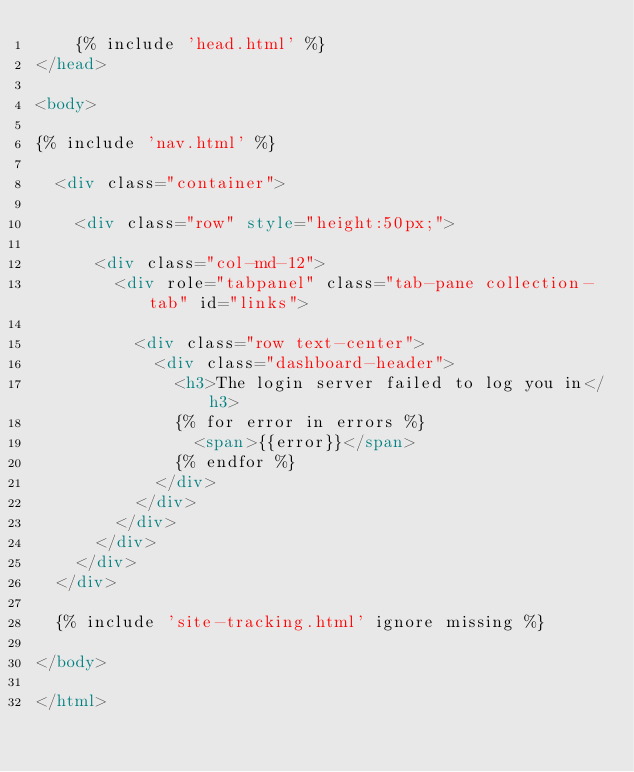<code> <loc_0><loc_0><loc_500><loc_500><_HTML_>    {% include 'head.html' %}
</head>

<body>

{% include 'nav.html' %}

	<div class="container">

		<div class="row" style="height:50px;">

			<div class="col-md-12">
				<div role="tabpanel" class="tab-pane collection-tab" id="links">

					<div class="row text-center">
						<div class="dashboard-header">
							<h3>The login server failed to log you in</h3>
							{% for error in errors %}
								<span>{{error}}</span>
							{% endfor %}
						</div>
					</div>
				</div>
			</div>
		</div>
	</div>

	{% include 'site-tracking.html' ignore missing %}

</body>

</html></code> 